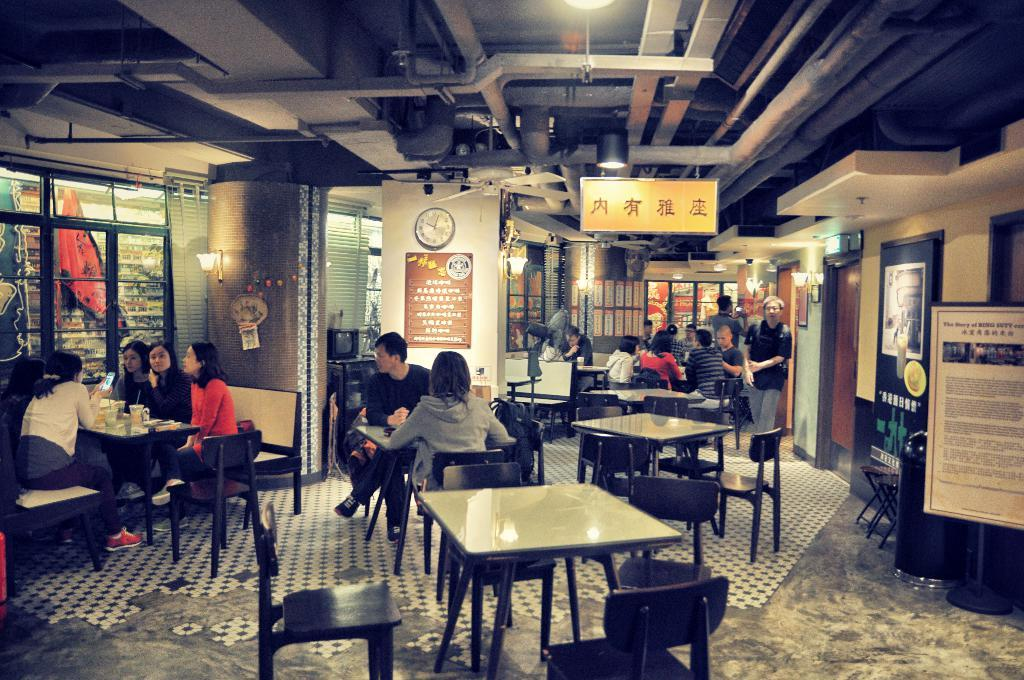How many people are in the image? There is a group of people in the image. Where are the people located in the image? The people are sitting in a restaurant. What is in front of the people? There is a table in front of the people. What can be seen on the table? The table has eatables and drinks on it. What type of thread is being used to weave a rug under the table in the image? There is no thread or rug visible in the image; it only shows a group of people sitting in a restaurant with a table in front of them. 